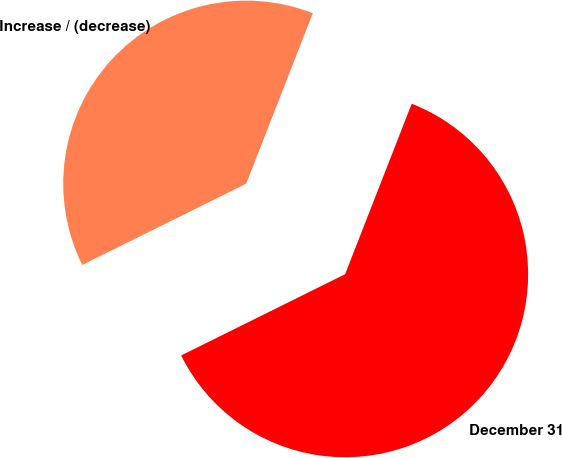<chart> <loc_0><loc_0><loc_500><loc_500><pie_chart><fcel>December 31<fcel>Increase / (decrease)<nl><fcel>61.75%<fcel>38.25%<nl></chart> 